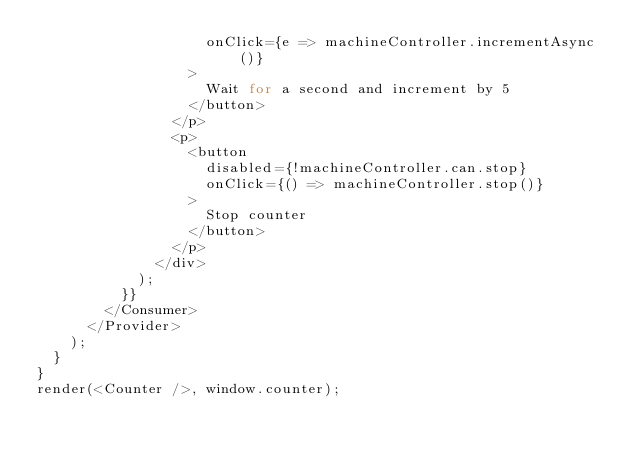<code> <loc_0><loc_0><loc_500><loc_500><_JavaScript_>                    onClick={e => machineController.incrementAsync()}
                  >
                    Wait for a second and increment by 5
                  </button>
                </p>
                <p>
                  <button
                    disabled={!machineController.can.stop}
                    onClick={() => machineController.stop()}
                  >
                    Stop counter
                  </button>
                </p>
              </div>
            );
          }}
        </Consumer>
      </Provider>
    );
  }
}
render(<Counter />, window.counter);
</code> 